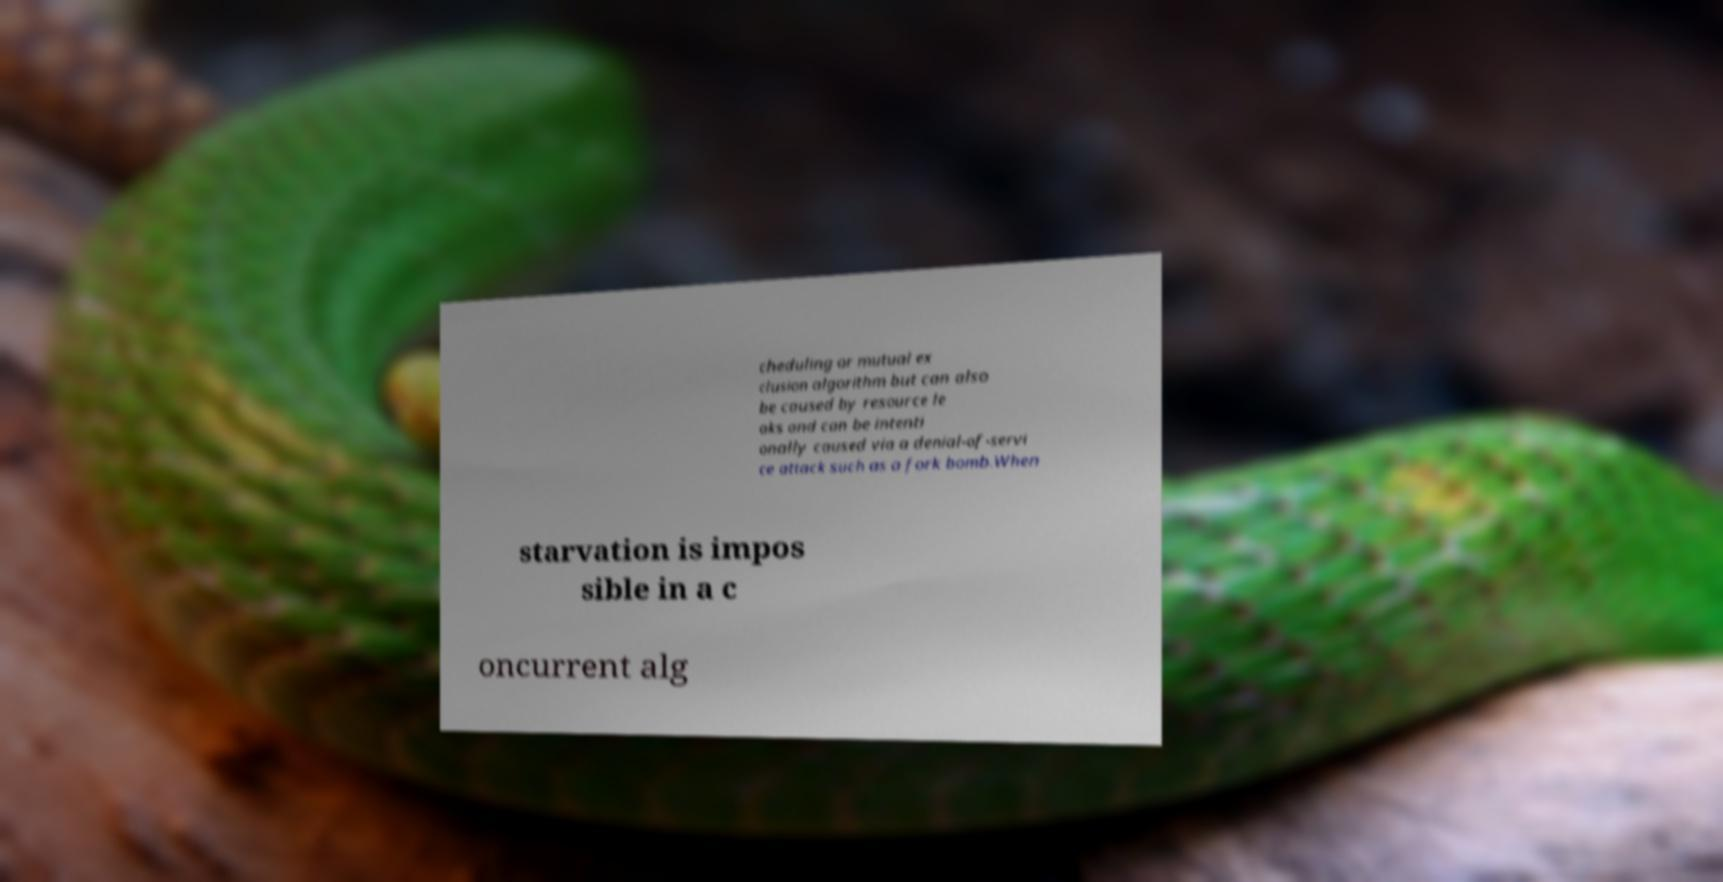Could you extract and type out the text from this image? cheduling or mutual ex clusion algorithm but can also be caused by resource le aks and can be intenti onally caused via a denial-of-servi ce attack such as a fork bomb.When starvation is impos sible in a c oncurrent alg 